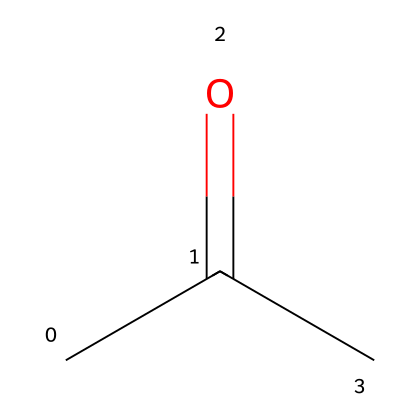What is the name of this chemical? The SMILES representation "CC(=O)C" corresponds to acetone, a simple and well-known organic solvent.
Answer: acetone How many carbon atoms are in this molecule? The structure depicted in the SMILES contains three carbon atoms, indicated by the "C" symbols.
Answer: 3 What type of functional group is present in this chemical? The "=O" in the structure indicates a carbonyl group, which is characteristic of ketones. Since acetone is a ketone, it specifically has a carbonyl functional group.
Answer: carbonyl What is the molecular formula of acetone? By analyzing the structure, acetone has three carbon atoms, six hydrogen atoms, and one oxygen atom, which combines to give the molecular formula C3H6O.
Answer: C3H6O Is acetone considered a flammable liquid? Acetone is known to be highly flammable due to its low flash point and volatility, classified as a flammable liquid according to safety standards.
Answer: yes Which part of the structure contributes to acetone's polarity? The oxygen atom in the carbonyl functional group contributes to the polarity of acetone due to the difference in electronegativity between carbon and oxygen, leading to dipole moments.
Answer: oxygen What is the boiling point range of acetone? Acetone has a boiling point around 56 degrees Celsius (132.8 degrees Fahrenheit), which is typical for a small polar organic molecule like acetone.
Answer: 56 degrees Celsius 